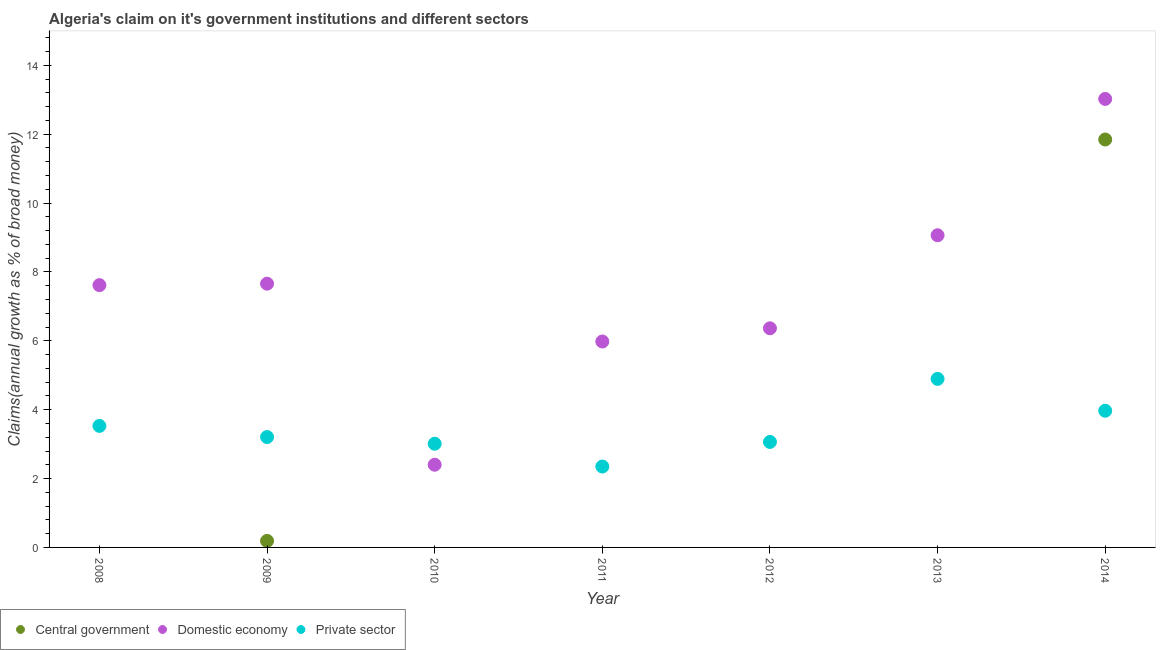Across all years, what is the maximum percentage of claim on the domestic economy?
Offer a terse response. 13.02. Across all years, what is the minimum percentage of claim on the domestic economy?
Offer a terse response. 2.4. What is the total percentage of claim on the domestic economy in the graph?
Offer a very short reply. 52.11. What is the difference between the percentage of claim on the domestic economy in 2008 and that in 2010?
Offer a terse response. 5.22. What is the difference between the percentage of claim on the private sector in 2014 and the percentage of claim on the domestic economy in 2009?
Your answer should be very brief. -3.69. What is the average percentage of claim on the private sector per year?
Provide a short and direct response. 3.43. In the year 2014, what is the difference between the percentage of claim on the domestic economy and percentage of claim on the private sector?
Provide a short and direct response. 9.05. In how many years, is the percentage of claim on the domestic economy greater than 1.6 %?
Offer a terse response. 7. What is the ratio of the percentage of claim on the central government in 2009 to that in 2014?
Offer a very short reply. 0.02. What is the difference between the highest and the second highest percentage of claim on the private sector?
Offer a very short reply. 0.92. What is the difference between the highest and the lowest percentage of claim on the domestic economy?
Your answer should be compact. 10.62. Is the percentage of claim on the central government strictly greater than the percentage of claim on the private sector over the years?
Give a very brief answer. No. How many years are there in the graph?
Offer a terse response. 7. What is the difference between two consecutive major ticks on the Y-axis?
Make the answer very short. 2. Does the graph contain grids?
Your answer should be very brief. No. How are the legend labels stacked?
Make the answer very short. Horizontal. What is the title of the graph?
Provide a succinct answer. Algeria's claim on it's government institutions and different sectors. What is the label or title of the X-axis?
Give a very brief answer. Year. What is the label or title of the Y-axis?
Provide a short and direct response. Claims(annual growth as % of broad money). What is the Claims(annual growth as % of broad money) of Central government in 2008?
Provide a short and direct response. 0. What is the Claims(annual growth as % of broad money) of Domestic economy in 2008?
Give a very brief answer. 7.62. What is the Claims(annual growth as % of broad money) of Private sector in 2008?
Your response must be concise. 3.53. What is the Claims(annual growth as % of broad money) in Central government in 2009?
Your response must be concise. 0.19. What is the Claims(annual growth as % of broad money) of Domestic economy in 2009?
Offer a terse response. 7.66. What is the Claims(annual growth as % of broad money) of Private sector in 2009?
Give a very brief answer. 3.21. What is the Claims(annual growth as % of broad money) in Domestic economy in 2010?
Keep it short and to the point. 2.4. What is the Claims(annual growth as % of broad money) of Private sector in 2010?
Ensure brevity in your answer.  3.01. What is the Claims(annual growth as % of broad money) of Domestic economy in 2011?
Provide a succinct answer. 5.98. What is the Claims(annual growth as % of broad money) in Private sector in 2011?
Offer a terse response. 2.35. What is the Claims(annual growth as % of broad money) in Domestic economy in 2012?
Offer a terse response. 6.36. What is the Claims(annual growth as % of broad money) in Private sector in 2012?
Make the answer very short. 3.06. What is the Claims(annual growth as % of broad money) in Central government in 2013?
Offer a terse response. 0. What is the Claims(annual growth as % of broad money) in Domestic economy in 2013?
Your answer should be very brief. 9.07. What is the Claims(annual growth as % of broad money) in Private sector in 2013?
Make the answer very short. 4.89. What is the Claims(annual growth as % of broad money) in Central government in 2014?
Keep it short and to the point. 11.85. What is the Claims(annual growth as % of broad money) of Domestic economy in 2014?
Keep it short and to the point. 13.02. What is the Claims(annual growth as % of broad money) in Private sector in 2014?
Your answer should be very brief. 3.97. Across all years, what is the maximum Claims(annual growth as % of broad money) in Central government?
Provide a succinct answer. 11.85. Across all years, what is the maximum Claims(annual growth as % of broad money) in Domestic economy?
Offer a very short reply. 13.02. Across all years, what is the maximum Claims(annual growth as % of broad money) of Private sector?
Provide a short and direct response. 4.89. Across all years, what is the minimum Claims(annual growth as % of broad money) in Domestic economy?
Your answer should be very brief. 2.4. Across all years, what is the minimum Claims(annual growth as % of broad money) in Private sector?
Make the answer very short. 2.35. What is the total Claims(annual growth as % of broad money) in Central government in the graph?
Keep it short and to the point. 12.04. What is the total Claims(annual growth as % of broad money) of Domestic economy in the graph?
Make the answer very short. 52.11. What is the total Claims(annual growth as % of broad money) of Private sector in the graph?
Provide a succinct answer. 24.02. What is the difference between the Claims(annual growth as % of broad money) of Domestic economy in 2008 and that in 2009?
Offer a very short reply. -0.04. What is the difference between the Claims(annual growth as % of broad money) in Private sector in 2008 and that in 2009?
Make the answer very short. 0.32. What is the difference between the Claims(annual growth as % of broad money) of Domestic economy in 2008 and that in 2010?
Ensure brevity in your answer.  5.22. What is the difference between the Claims(annual growth as % of broad money) of Private sector in 2008 and that in 2010?
Make the answer very short. 0.52. What is the difference between the Claims(annual growth as % of broad money) of Domestic economy in 2008 and that in 2011?
Offer a terse response. 1.64. What is the difference between the Claims(annual growth as % of broad money) of Private sector in 2008 and that in 2011?
Make the answer very short. 1.18. What is the difference between the Claims(annual growth as % of broad money) of Domestic economy in 2008 and that in 2012?
Offer a terse response. 1.25. What is the difference between the Claims(annual growth as % of broad money) in Private sector in 2008 and that in 2012?
Keep it short and to the point. 0.47. What is the difference between the Claims(annual growth as % of broad money) in Domestic economy in 2008 and that in 2013?
Make the answer very short. -1.45. What is the difference between the Claims(annual growth as % of broad money) of Private sector in 2008 and that in 2013?
Make the answer very short. -1.37. What is the difference between the Claims(annual growth as % of broad money) in Domestic economy in 2008 and that in 2014?
Give a very brief answer. -5.41. What is the difference between the Claims(annual growth as % of broad money) in Private sector in 2008 and that in 2014?
Offer a terse response. -0.44. What is the difference between the Claims(annual growth as % of broad money) in Domestic economy in 2009 and that in 2010?
Provide a succinct answer. 5.26. What is the difference between the Claims(annual growth as % of broad money) in Private sector in 2009 and that in 2010?
Offer a terse response. 0.19. What is the difference between the Claims(annual growth as % of broad money) of Domestic economy in 2009 and that in 2011?
Ensure brevity in your answer.  1.68. What is the difference between the Claims(annual growth as % of broad money) of Private sector in 2009 and that in 2011?
Provide a short and direct response. 0.86. What is the difference between the Claims(annual growth as % of broad money) of Domestic economy in 2009 and that in 2012?
Offer a very short reply. 1.3. What is the difference between the Claims(annual growth as % of broad money) of Private sector in 2009 and that in 2012?
Ensure brevity in your answer.  0.14. What is the difference between the Claims(annual growth as % of broad money) in Domestic economy in 2009 and that in 2013?
Your response must be concise. -1.41. What is the difference between the Claims(annual growth as % of broad money) of Private sector in 2009 and that in 2013?
Your answer should be compact. -1.69. What is the difference between the Claims(annual growth as % of broad money) in Central government in 2009 and that in 2014?
Offer a terse response. -11.66. What is the difference between the Claims(annual growth as % of broad money) of Domestic economy in 2009 and that in 2014?
Offer a very short reply. -5.36. What is the difference between the Claims(annual growth as % of broad money) of Private sector in 2009 and that in 2014?
Make the answer very short. -0.76. What is the difference between the Claims(annual growth as % of broad money) of Domestic economy in 2010 and that in 2011?
Offer a very short reply. -3.58. What is the difference between the Claims(annual growth as % of broad money) in Private sector in 2010 and that in 2011?
Provide a short and direct response. 0.66. What is the difference between the Claims(annual growth as % of broad money) of Domestic economy in 2010 and that in 2012?
Ensure brevity in your answer.  -3.96. What is the difference between the Claims(annual growth as % of broad money) in Private sector in 2010 and that in 2012?
Provide a succinct answer. -0.05. What is the difference between the Claims(annual growth as % of broad money) in Domestic economy in 2010 and that in 2013?
Make the answer very short. -6.66. What is the difference between the Claims(annual growth as % of broad money) of Private sector in 2010 and that in 2013?
Your response must be concise. -1.88. What is the difference between the Claims(annual growth as % of broad money) in Domestic economy in 2010 and that in 2014?
Your answer should be very brief. -10.62. What is the difference between the Claims(annual growth as % of broad money) of Private sector in 2010 and that in 2014?
Keep it short and to the point. -0.96. What is the difference between the Claims(annual growth as % of broad money) of Domestic economy in 2011 and that in 2012?
Your response must be concise. -0.38. What is the difference between the Claims(annual growth as % of broad money) of Private sector in 2011 and that in 2012?
Provide a short and direct response. -0.71. What is the difference between the Claims(annual growth as % of broad money) in Domestic economy in 2011 and that in 2013?
Ensure brevity in your answer.  -3.09. What is the difference between the Claims(annual growth as % of broad money) in Private sector in 2011 and that in 2013?
Your answer should be very brief. -2.55. What is the difference between the Claims(annual growth as % of broad money) in Domestic economy in 2011 and that in 2014?
Your response must be concise. -7.04. What is the difference between the Claims(annual growth as % of broad money) in Private sector in 2011 and that in 2014?
Your response must be concise. -1.62. What is the difference between the Claims(annual growth as % of broad money) of Domestic economy in 2012 and that in 2013?
Your response must be concise. -2.7. What is the difference between the Claims(annual growth as % of broad money) in Private sector in 2012 and that in 2013?
Ensure brevity in your answer.  -1.83. What is the difference between the Claims(annual growth as % of broad money) in Domestic economy in 2012 and that in 2014?
Provide a short and direct response. -6.66. What is the difference between the Claims(annual growth as % of broad money) in Private sector in 2012 and that in 2014?
Your answer should be compact. -0.91. What is the difference between the Claims(annual growth as % of broad money) in Domestic economy in 2013 and that in 2014?
Offer a terse response. -3.96. What is the difference between the Claims(annual growth as % of broad money) in Private sector in 2013 and that in 2014?
Provide a short and direct response. 0.92. What is the difference between the Claims(annual growth as % of broad money) in Domestic economy in 2008 and the Claims(annual growth as % of broad money) in Private sector in 2009?
Your answer should be very brief. 4.41. What is the difference between the Claims(annual growth as % of broad money) in Domestic economy in 2008 and the Claims(annual growth as % of broad money) in Private sector in 2010?
Offer a terse response. 4.61. What is the difference between the Claims(annual growth as % of broad money) of Domestic economy in 2008 and the Claims(annual growth as % of broad money) of Private sector in 2011?
Your answer should be very brief. 5.27. What is the difference between the Claims(annual growth as % of broad money) of Domestic economy in 2008 and the Claims(annual growth as % of broad money) of Private sector in 2012?
Provide a succinct answer. 4.55. What is the difference between the Claims(annual growth as % of broad money) of Domestic economy in 2008 and the Claims(annual growth as % of broad money) of Private sector in 2013?
Keep it short and to the point. 2.72. What is the difference between the Claims(annual growth as % of broad money) of Domestic economy in 2008 and the Claims(annual growth as % of broad money) of Private sector in 2014?
Keep it short and to the point. 3.65. What is the difference between the Claims(annual growth as % of broad money) in Central government in 2009 and the Claims(annual growth as % of broad money) in Domestic economy in 2010?
Offer a very short reply. -2.21. What is the difference between the Claims(annual growth as % of broad money) of Central government in 2009 and the Claims(annual growth as % of broad money) of Private sector in 2010?
Ensure brevity in your answer.  -2.82. What is the difference between the Claims(annual growth as % of broad money) in Domestic economy in 2009 and the Claims(annual growth as % of broad money) in Private sector in 2010?
Ensure brevity in your answer.  4.65. What is the difference between the Claims(annual growth as % of broad money) of Central government in 2009 and the Claims(annual growth as % of broad money) of Domestic economy in 2011?
Offer a very short reply. -5.79. What is the difference between the Claims(annual growth as % of broad money) in Central government in 2009 and the Claims(annual growth as % of broad money) in Private sector in 2011?
Ensure brevity in your answer.  -2.16. What is the difference between the Claims(annual growth as % of broad money) in Domestic economy in 2009 and the Claims(annual growth as % of broad money) in Private sector in 2011?
Provide a short and direct response. 5.31. What is the difference between the Claims(annual growth as % of broad money) of Central government in 2009 and the Claims(annual growth as % of broad money) of Domestic economy in 2012?
Give a very brief answer. -6.17. What is the difference between the Claims(annual growth as % of broad money) in Central government in 2009 and the Claims(annual growth as % of broad money) in Private sector in 2012?
Ensure brevity in your answer.  -2.87. What is the difference between the Claims(annual growth as % of broad money) of Domestic economy in 2009 and the Claims(annual growth as % of broad money) of Private sector in 2012?
Provide a succinct answer. 4.6. What is the difference between the Claims(annual growth as % of broad money) in Central government in 2009 and the Claims(annual growth as % of broad money) in Domestic economy in 2013?
Provide a short and direct response. -8.88. What is the difference between the Claims(annual growth as % of broad money) in Central government in 2009 and the Claims(annual growth as % of broad money) in Private sector in 2013?
Give a very brief answer. -4.71. What is the difference between the Claims(annual growth as % of broad money) of Domestic economy in 2009 and the Claims(annual growth as % of broad money) of Private sector in 2013?
Your response must be concise. 2.77. What is the difference between the Claims(annual growth as % of broad money) of Central government in 2009 and the Claims(annual growth as % of broad money) of Domestic economy in 2014?
Offer a terse response. -12.84. What is the difference between the Claims(annual growth as % of broad money) of Central government in 2009 and the Claims(annual growth as % of broad money) of Private sector in 2014?
Make the answer very short. -3.78. What is the difference between the Claims(annual growth as % of broad money) in Domestic economy in 2009 and the Claims(annual growth as % of broad money) in Private sector in 2014?
Offer a very short reply. 3.69. What is the difference between the Claims(annual growth as % of broad money) of Domestic economy in 2010 and the Claims(annual growth as % of broad money) of Private sector in 2011?
Your answer should be very brief. 0.05. What is the difference between the Claims(annual growth as % of broad money) of Domestic economy in 2010 and the Claims(annual growth as % of broad money) of Private sector in 2012?
Your answer should be very brief. -0.66. What is the difference between the Claims(annual growth as % of broad money) of Domestic economy in 2010 and the Claims(annual growth as % of broad money) of Private sector in 2013?
Offer a terse response. -2.49. What is the difference between the Claims(annual growth as % of broad money) of Domestic economy in 2010 and the Claims(annual growth as % of broad money) of Private sector in 2014?
Ensure brevity in your answer.  -1.57. What is the difference between the Claims(annual growth as % of broad money) in Domestic economy in 2011 and the Claims(annual growth as % of broad money) in Private sector in 2012?
Provide a short and direct response. 2.92. What is the difference between the Claims(annual growth as % of broad money) in Domestic economy in 2011 and the Claims(annual growth as % of broad money) in Private sector in 2013?
Your answer should be very brief. 1.09. What is the difference between the Claims(annual growth as % of broad money) in Domestic economy in 2011 and the Claims(annual growth as % of broad money) in Private sector in 2014?
Keep it short and to the point. 2.01. What is the difference between the Claims(annual growth as % of broad money) in Domestic economy in 2012 and the Claims(annual growth as % of broad money) in Private sector in 2013?
Ensure brevity in your answer.  1.47. What is the difference between the Claims(annual growth as % of broad money) of Domestic economy in 2012 and the Claims(annual growth as % of broad money) of Private sector in 2014?
Make the answer very short. 2.39. What is the difference between the Claims(annual growth as % of broad money) of Domestic economy in 2013 and the Claims(annual growth as % of broad money) of Private sector in 2014?
Provide a short and direct response. 5.1. What is the average Claims(annual growth as % of broad money) in Central government per year?
Offer a very short reply. 1.72. What is the average Claims(annual growth as % of broad money) in Domestic economy per year?
Keep it short and to the point. 7.44. What is the average Claims(annual growth as % of broad money) in Private sector per year?
Provide a short and direct response. 3.43. In the year 2008, what is the difference between the Claims(annual growth as % of broad money) of Domestic economy and Claims(annual growth as % of broad money) of Private sector?
Offer a terse response. 4.09. In the year 2009, what is the difference between the Claims(annual growth as % of broad money) in Central government and Claims(annual growth as % of broad money) in Domestic economy?
Make the answer very short. -7.47. In the year 2009, what is the difference between the Claims(annual growth as % of broad money) in Central government and Claims(annual growth as % of broad money) in Private sector?
Provide a succinct answer. -3.02. In the year 2009, what is the difference between the Claims(annual growth as % of broad money) of Domestic economy and Claims(annual growth as % of broad money) of Private sector?
Keep it short and to the point. 4.45. In the year 2010, what is the difference between the Claims(annual growth as % of broad money) of Domestic economy and Claims(annual growth as % of broad money) of Private sector?
Provide a short and direct response. -0.61. In the year 2011, what is the difference between the Claims(annual growth as % of broad money) in Domestic economy and Claims(annual growth as % of broad money) in Private sector?
Make the answer very short. 3.63. In the year 2012, what is the difference between the Claims(annual growth as % of broad money) of Domestic economy and Claims(annual growth as % of broad money) of Private sector?
Your answer should be compact. 3.3. In the year 2013, what is the difference between the Claims(annual growth as % of broad money) of Domestic economy and Claims(annual growth as % of broad money) of Private sector?
Your response must be concise. 4.17. In the year 2014, what is the difference between the Claims(annual growth as % of broad money) of Central government and Claims(annual growth as % of broad money) of Domestic economy?
Offer a very short reply. -1.18. In the year 2014, what is the difference between the Claims(annual growth as % of broad money) of Central government and Claims(annual growth as % of broad money) of Private sector?
Make the answer very short. 7.88. In the year 2014, what is the difference between the Claims(annual growth as % of broad money) in Domestic economy and Claims(annual growth as % of broad money) in Private sector?
Ensure brevity in your answer.  9.05. What is the ratio of the Claims(annual growth as % of broad money) in Domestic economy in 2008 to that in 2009?
Keep it short and to the point. 0.99. What is the ratio of the Claims(annual growth as % of broad money) of Private sector in 2008 to that in 2009?
Your answer should be compact. 1.1. What is the ratio of the Claims(annual growth as % of broad money) in Domestic economy in 2008 to that in 2010?
Make the answer very short. 3.17. What is the ratio of the Claims(annual growth as % of broad money) in Private sector in 2008 to that in 2010?
Provide a succinct answer. 1.17. What is the ratio of the Claims(annual growth as % of broad money) in Domestic economy in 2008 to that in 2011?
Your answer should be very brief. 1.27. What is the ratio of the Claims(annual growth as % of broad money) in Private sector in 2008 to that in 2011?
Give a very brief answer. 1.5. What is the ratio of the Claims(annual growth as % of broad money) in Domestic economy in 2008 to that in 2012?
Your response must be concise. 1.2. What is the ratio of the Claims(annual growth as % of broad money) of Private sector in 2008 to that in 2012?
Your answer should be very brief. 1.15. What is the ratio of the Claims(annual growth as % of broad money) of Domestic economy in 2008 to that in 2013?
Your response must be concise. 0.84. What is the ratio of the Claims(annual growth as % of broad money) of Private sector in 2008 to that in 2013?
Provide a succinct answer. 0.72. What is the ratio of the Claims(annual growth as % of broad money) in Domestic economy in 2008 to that in 2014?
Make the answer very short. 0.58. What is the ratio of the Claims(annual growth as % of broad money) in Private sector in 2008 to that in 2014?
Offer a terse response. 0.89. What is the ratio of the Claims(annual growth as % of broad money) of Domestic economy in 2009 to that in 2010?
Your response must be concise. 3.19. What is the ratio of the Claims(annual growth as % of broad money) of Private sector in 2009 to that in 2010?
Provide a short and direct response. 1.06. What is the ratio of the Claims(annual growth as % of broad money) in Domestic economy in 2009 to that in 2011?
Ensure brevity in your answer.  1.28. What is the ratio of the Claims(annual growth as % of broad money) in Private sector in 2009 to that in 2011?
Give a very brief answer. 1.36. What is the ratio of the Claims(annual growth as % of broad money) of Domestic economy in 2009 to that in 2012?
Provide a short and direct response. 1.2. What is the ratio of the Claims(annual growth as % of broad money) of Private sector in 2009 to that in 2012?
Provide a short and direct response. 1.05. What is the ratio of the Claims(annual growth as % of broad money) of Domestic economy in 2009 to that in 2013?
Provide a short and direct response. 0.84. What is the ratio of the Claims(annual growth as % of broad money) of Private sector in 2009 to that in 2013?
Your answer should be very brief. 0.66. What is the ratio of the Claims(annual growth as % of broad money) in Central government in 2009 to that in 2014?
Keep it short and to the point. 0.02. What is the ratio of the Claims(annual growth as % of broad money) in Domestic economy in 2009 to that in 2014?
Your answer should be very brief. 0.59. What is the ratio of the Claims(annual growth as % of broad money) of Private sector in 2009 to that in 2014?
Offer a very short reply. 0.81. What is the ratio of the Claims(annual growth as % of broad money) in Domestic economy in 2010 to that in 2011?
Your answer should be very brief. 0.4. What is the ratio of the Claims(annual growth as % of broad money) in Private sector in 2010 to that in 2011?
Your answer should be very brief. 1.28. What is the ratio of the Claims(annual growth as % of broad money) in Domestic economy in 2010 to that in 2012?
Provide a short and direct response. 0.38. What is the ratio of the Claims(annual growth as % of broad money) in Domestic economy in 2010 to that in 2013?
Keep it short and to the point. 0.26. What is the ratio of the Claims(annual growth as % of broad money) in Private sector in 2010 to that in 2013?
Your response must be concise. 0.62. What is the ratio of the Claims(annual growth as % of broad money) of Domestic economy in 2010 to that in 2014?
Offer a terse response. 0.18. What is the ratio of the Claims(annual growth as % of broad money) in Private sector in 2010 to that in 2014?
Provide a short and direct response. 0.76. What is the ratio of the Claims(annual growth as % of broad money) of Domestic economy in 2011 to that in 2012?
Offer a very short reply. 0.94. What is the ratio of the Claims(annual growth as % of broad money) of Private sector in 2011 to that in 2012?
Your answer should be very brief. 0.77. What is the ratio of the Claims(annual growth as % of broad money) in Domestic economy in 2011 to that in 2013?
Provide a short and direct response. 0.66. What is the ratio of the Claims(annual growth as % of broad money) of Private sector in 2011 to that in 2013?
Your response must be concise. 0.48. What is the ratio of the Claims(annual growth as % of broad money) of Domestic economy in 2011 to that in 2014?
Your response must be concise. 0.46. What is the ratio of the Claims(annual growth as % of broad money) of Private sector in 2011 to that in 2014?
Your answer should be very brief. 0.59. What is the ratio of the Claims(annual growth as % of broad money) of Domestic economy in 2012 to that in 2013?
Your response must be concise. 0.7. What is the ratio of the Claims(annual growth as % of broad money) in Private sector in 2012 to that in 2013?
Offer a terse response. 0.63. What is the ratio of the Claims(annual growth as % of broad money) of Domestic economy in 2012 to that in 2014?
Make the answer very short. 0.49. What is the ratio of the Claims(annual growth as % of broad money) in Private sector in 2012 to that in 2014?
Provide a succinct answer. 0.77. What is the ratio of the Claims(annual growth as % of broad money) of Domestic economy in 2013 to that in 2014?
Provide a short and direct response. 0.7. What is the ratio of the Claims(annual growth as % of broad money) in Private sector in 2013 to that in 2014?
Provide a succinct answer. 1.23. What is the difference between the highest and the second highest Claims(annual growth as % of broad money) of Domestic economy?
Offer a terse response. 3.96. What is the difference between the highest and the second highest Claims(annual growth as % of broad money) of Private sector?
Ensure brevity in your answer.  0.92. What is the difference between the highest and the lowest Claims(annual growth as % of broad money) in Central government?
Your response must be concise. 11.85. What is the difference between the highest and the lowest Claims(annual growth as % of broad money) of Domestic economy?
Ensure brevity in your answer.  10.62. What is the difference between the highest and the lowest Claims(annual growth as % of broad money) in Private sector?
Offer a very short reply. 2.55. 